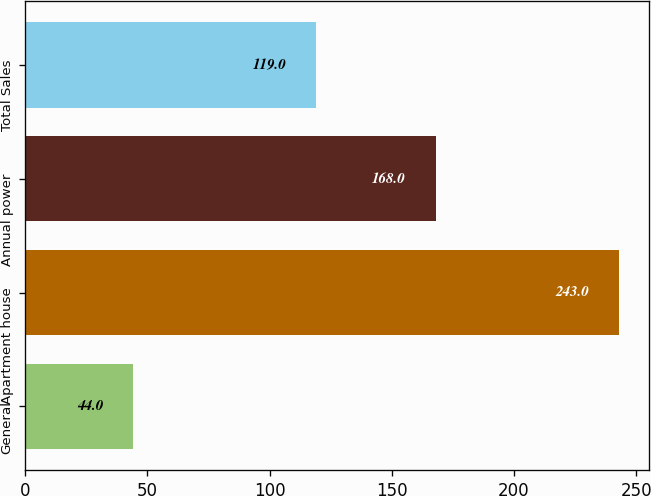Convert chart. <chart><loc_0><loc_0><loc_500><loc_500><bar_chart><fcel>General<fcel>Apartment house<fcel>Annual power<fcel>Total Sales<nl><fcel>44<fcel>243<fcel>168<fcel>119<nl></chart> 